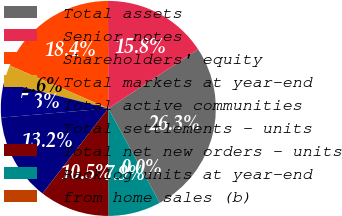<chart> <loc_0><loc_0><loc_500><loc_500><pie_chart><fcel>Total assets<fcel>Senior notes<fcel>Shareholders' equity<fcel>Total markets at year-end<fcel>Total active communities<fcel>Total settlements - units<fcel>Total net new orders - units<fcel>Backlog units at year-end<fcel>from home sales (b)<nl><fcel>26.32%<fcel>15.79%<fcel>18.42%<fcel>2.63%<fcel>5.26%<fcel>13.16%<fcel>10.53%<fcel>7.89%<fcel>0.0%<nl></chart> 